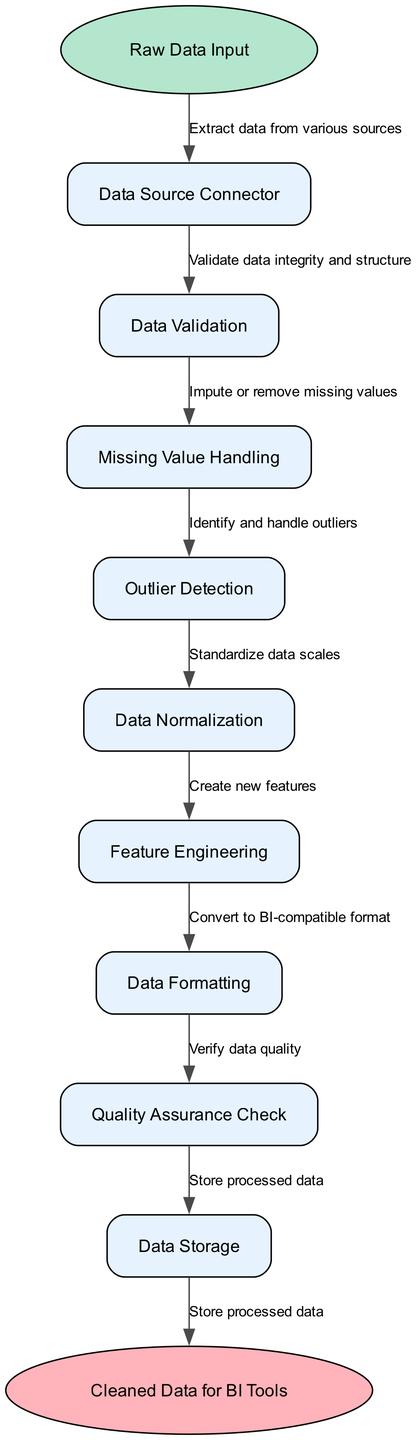What is the first node in the diagram? The first node is labeled "Raw Data Input". It is visually represented as an ellipse at the top of the flow chart, indicating the starting point for the data cleansing process.
Answer: Raw Data Input How many nodes are present in the diagram? There are a total of 9 nodes in the diagram, including the start and end nodes. These are counted from the "Raw Data Input" start node to the "Cleaned Data for BI Tools" end node.
Answer: 9 What does the last node represent? The last node is labeled "Cleaned Data for BI Tools", indicating the final output of the data cleansing and preprocessing pipeline before being used in business intelligence tools.
Answer: Cleaned Data for BI Tools What is the function of the "Data Validation" node? The "Data Validation" node serves to validate the integrity and structure of the incoming data. This involves checking for any inconsistencies or errors before processing further.
Answer: Validate data integrity and structure Which node is responsible for identifying and handling outliers? The "Outlier Detection" node is responsible for identifying and handling outliers in the dataset. This helps remove or adjust data points that could skew results.
Answer: Outlier Detection What process follows the "Missing Value Handling" node? The process that follows "Missing Value Handling" is "Outlier Detection". This indicates that after addressing missing values, the pipeline checks for outliers in the data.
Answer: Outlier Detection What type of data processing is indicated by the "Data Normalization" node? The "Data Normalization" node indicates the standardization of data scales. This process is essential to ensure that different features contribute equally in data analysis.
Answer: Standardize data scales Which step includes the creation of new features? The "Feature Engineering" step includes the creation of new features, which may involve transforming existing data into more useful forms for analysis.
Answer: Create new features What is the last operation that occurs before storing the processed data? The last operation before storing processed data is the "Quality Assurance Check". This step ensures that the data meets the required quality standards before storage.
Answer: Verify data quality 